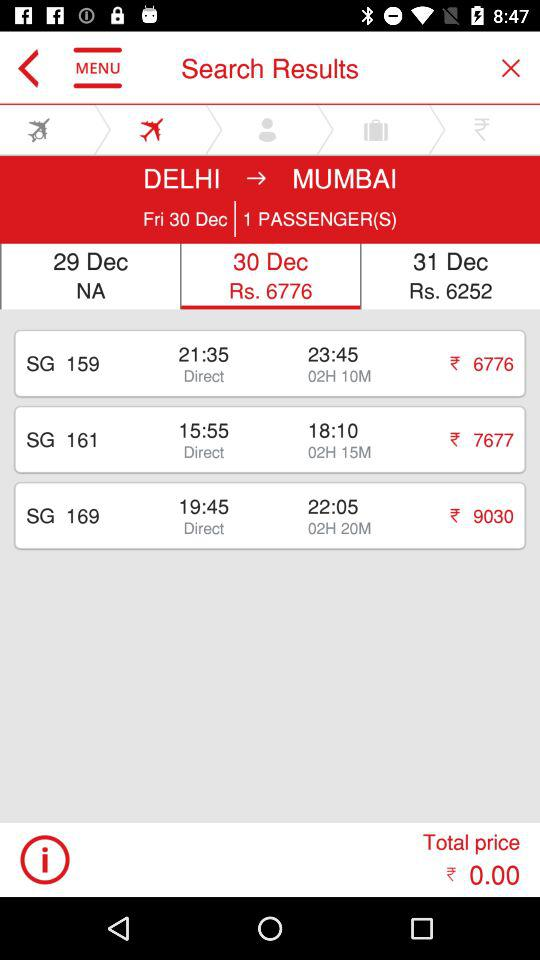What is the departure time of "SG 169"? The departure time is 19:45. 